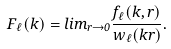Convert formula to latex. <formula><loc_0><loc_0><loc_500><loc_500>F _ { \ell } ( k ) = l i m _ { r \to 0 } \frac { f _ { \ell } ( k , r ) } { w _ { \ell } ( k r ) } .</formula> 